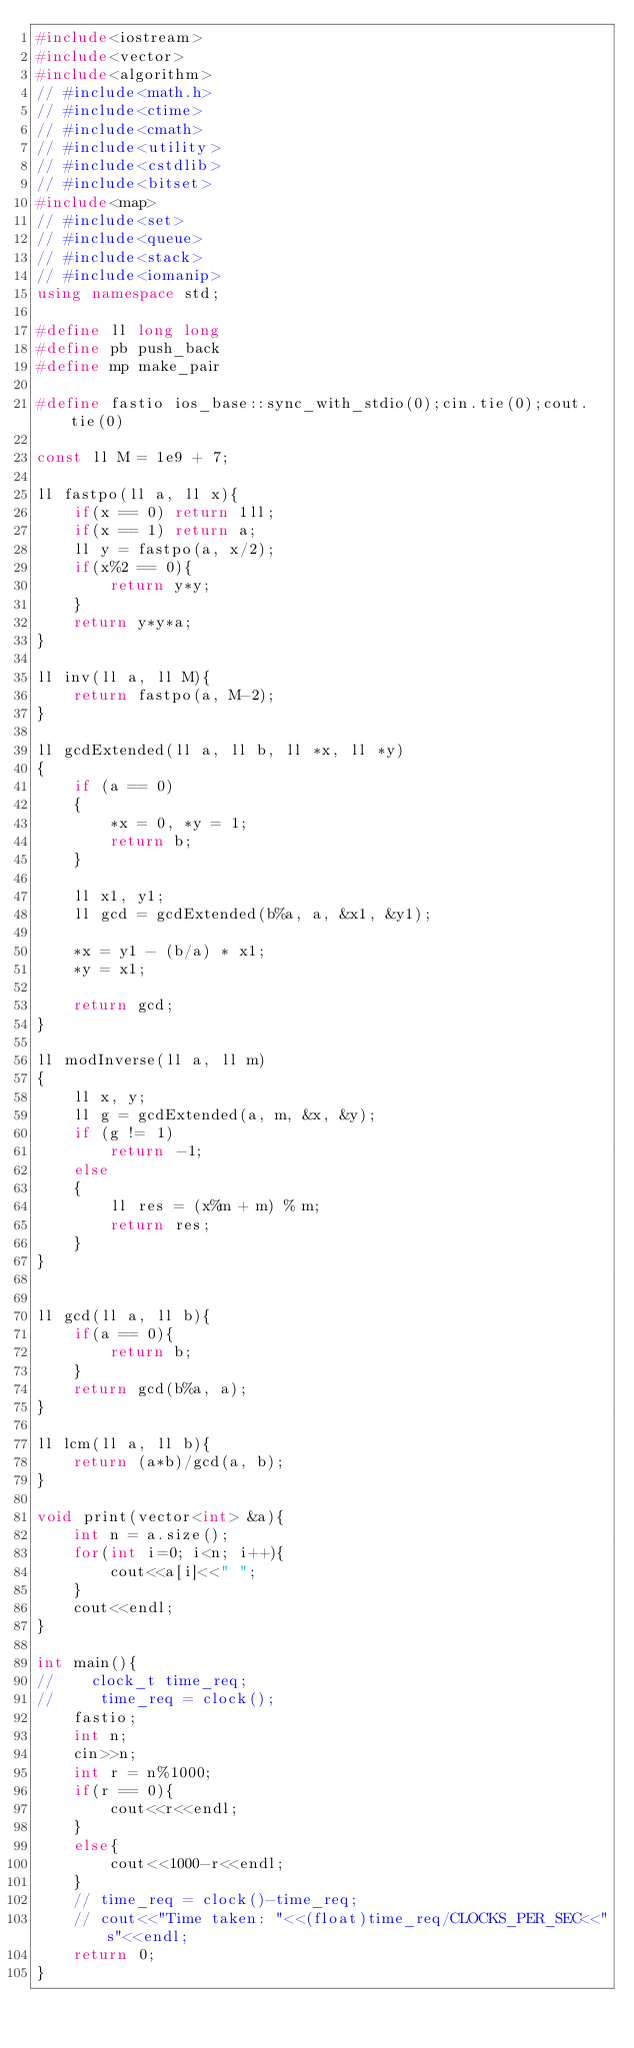Convert code to text. <code><loc_0><loc_0><loc_500><loc_500><_C++_>#include<iostream>
#include<vector>
#include<algorithm>
// #include<math.h>
// #include<ctime>
// #include<cmath>
// #include<utility>
// #include<cstdlib>
// #include<bitset>
#include<map>
// #include<set>
// #include<queue>
// #include<stack>
// #include<iomanip>
using namespace std;                       

#define ll long long
#define pb push_back
#define mp make_pair

#define fastio ios_base::sync_with_stdio(0);cin.tie(0);cout.tie(0)

const ll M = 1e9 + 7;

ll fastpo(ll a, ll x){
    if(x == 0) return 1ll;
    if(x == 1) return a;
    ll y = fastpo(a, x/2);
    if(x%2 == 0){
        return y*y;
    }
    return y*y*a;
}

ll inv(ll a, ll M){
    return fastpo(a, M-2);
}

ll gcdExtended(ll a, ll b, ll *x, ll *y) 
{ 
    if (a == 0) 
    { 
        *x = 0, *y = 1; 
        return b; 
    } 
  
    ll x1, y1; 
    ll gcd = gcdExtended(b%a, a, &x1, &y1); 
  
    *x = y1 - (b/a) * x1; 
    *y = x1; 
  
    return gcd; 
}

ll modInverse(ll a, ll m) 
{ 
    ll x, y; 
    ll g = gcdExtended(a, m, &x, &y); 
    if (g != 1) 
        return -1; 
    else
    { 
        ll res = (x%m + m) % m; 
        return res;
    } 
}


ll gcd(ll a, ll b){
    if(a == 0){
        return b;
    }
    return gcd(b%a, a);
}

ll lcm(ll a, ll b){
    return (a*b)/gcd(a, b);
}

void print(vector<int> &a){
    int n = a.size();
    for(int i=0; i<n; i++){
        cout<<a[i]<<" ";
    }
    cout<<endl;
}

int main(){
//    clock_t time_req;
//     time_req = clock();
    fastio;
    int n;
    cin>>n;
    int r = n%1000;
    if(r == 0){
        cout<<r<<endl;
    }
    else{
        cout<<1000-r<<endl;
    }
    // time_req = clock()-time_req;
    // cout<<"Time taken: "<<(float)time_req/CLOCKS_PER_SEC<<"s"<<endl;
    return 0;
}</code> 